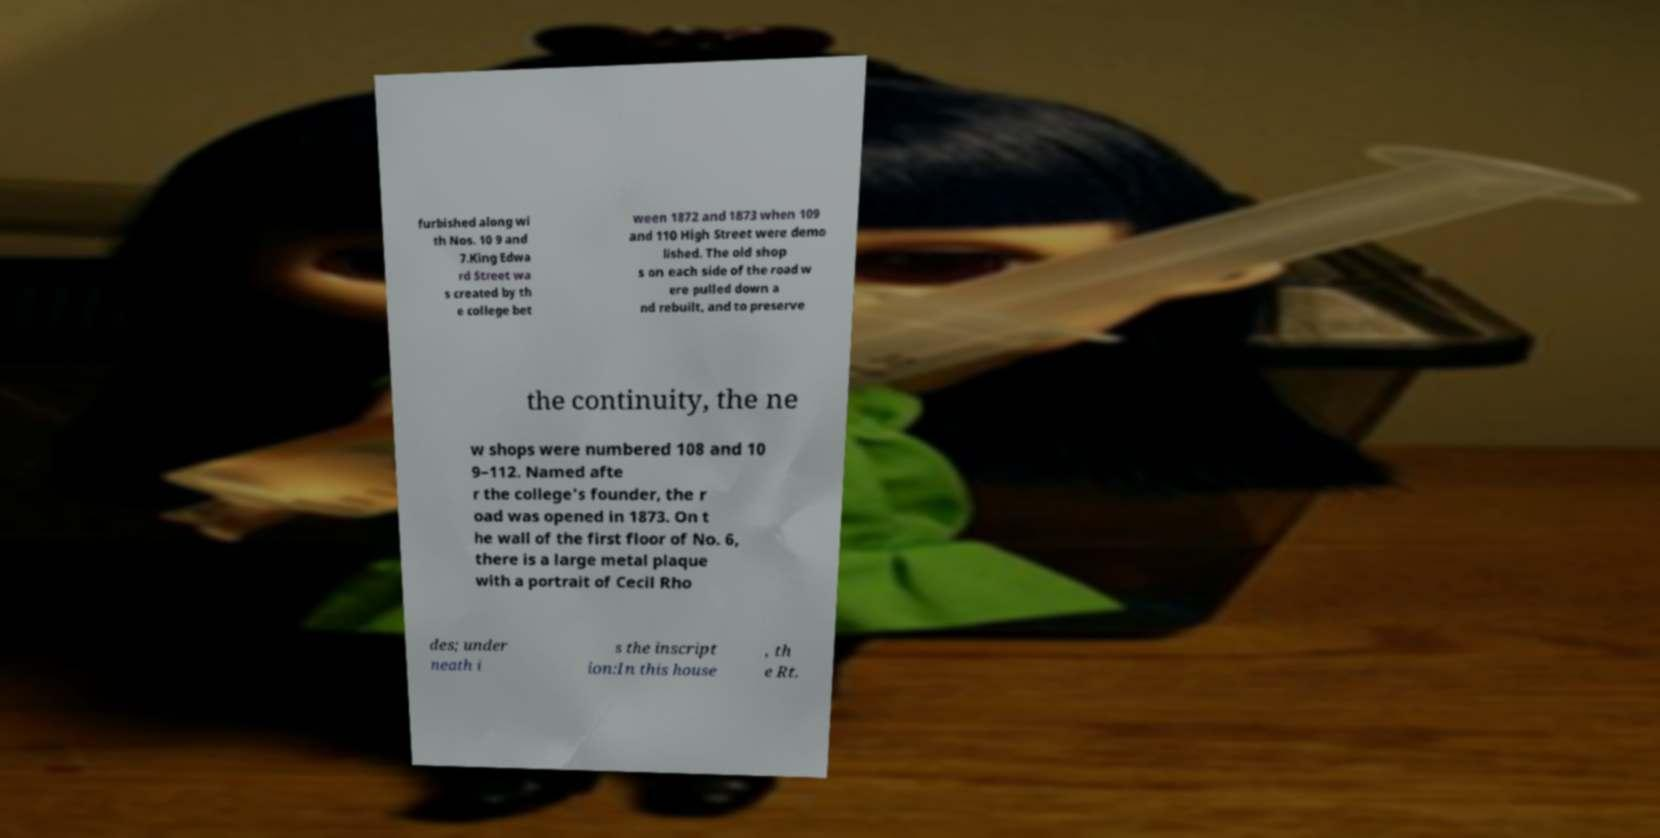I need the written content from this picture converted into text. Can you do that? furbished along wi th Nos. 10 9 and 7.King Edwa rd Street wa s created by th e college bet ween 1872 and 1873 when 109 and 110 High Street were demo lished. The old shop s on each side of the road w ere pulled down a nd rebuilt, and to preserve the continuity, the ne w shops were numbered 108 and 10 9–112. Named afte r the college's founder, the r oad was opened in 1873. On t he wall of the first floor of No. 6, there is a large metal plaque with a portrait of Cecil Rho des; under neath i s the inscript ion:In this house , th e Rt. 